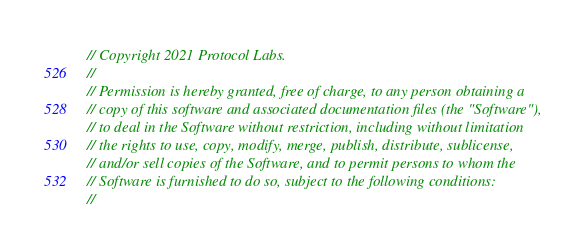Convert code to text. <code><loc_0><loc_0><loc_500><loc_500><_Rust_>// Copyright 2021 Protocol Labs.
//
// Permission is hereby granted, free of charge, to any person obtaining a
// copy of this software and associated documentation files (the "Software"),
// to deal in the Software without restriction, including without limitation
// the rights to use, copy, modify, merge, publish, distribute, sublicense,
// and/or sell copies of the Software, and to permit persons to whom the
// Software is furnished to do so, subject to the following conditions:
//</code> 